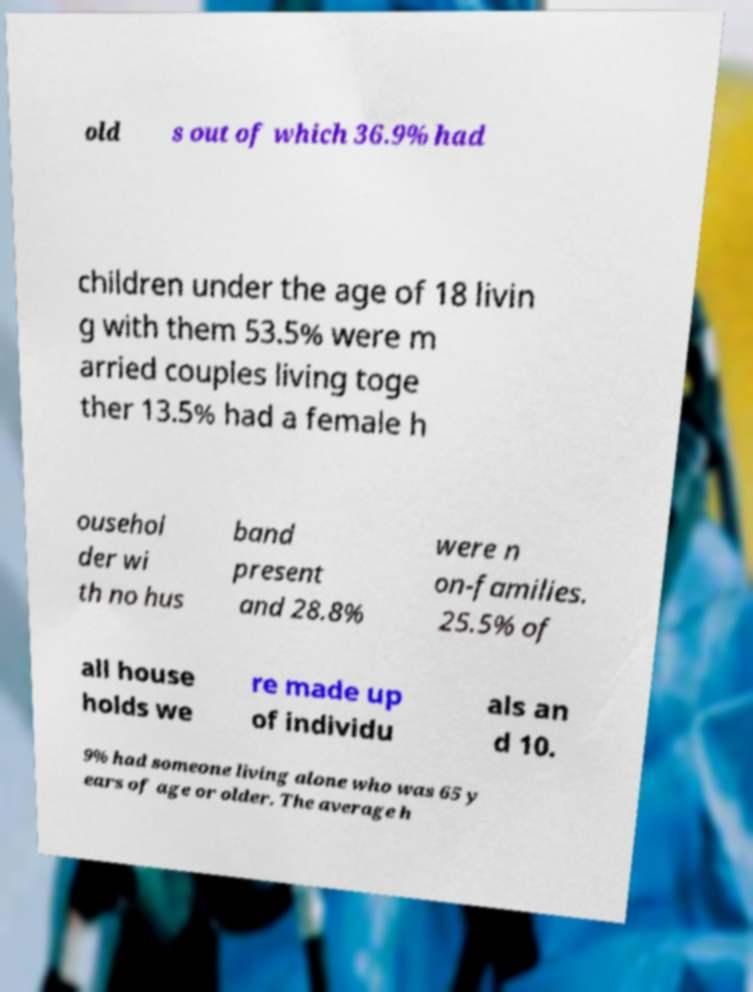Please identify and transcribe the text found in this image. old s out of which 36.9% had children under the age of 18 livin g with them 53.5% were m arried couples living toge ther 13.5% had a female h ousehol der wi th no hus band present and 28.8% were n on-families. 25.5% of all house holds we re made up of individu als an d 10. 9% had someone living alone who was 65 y ears of age or older. The average h 